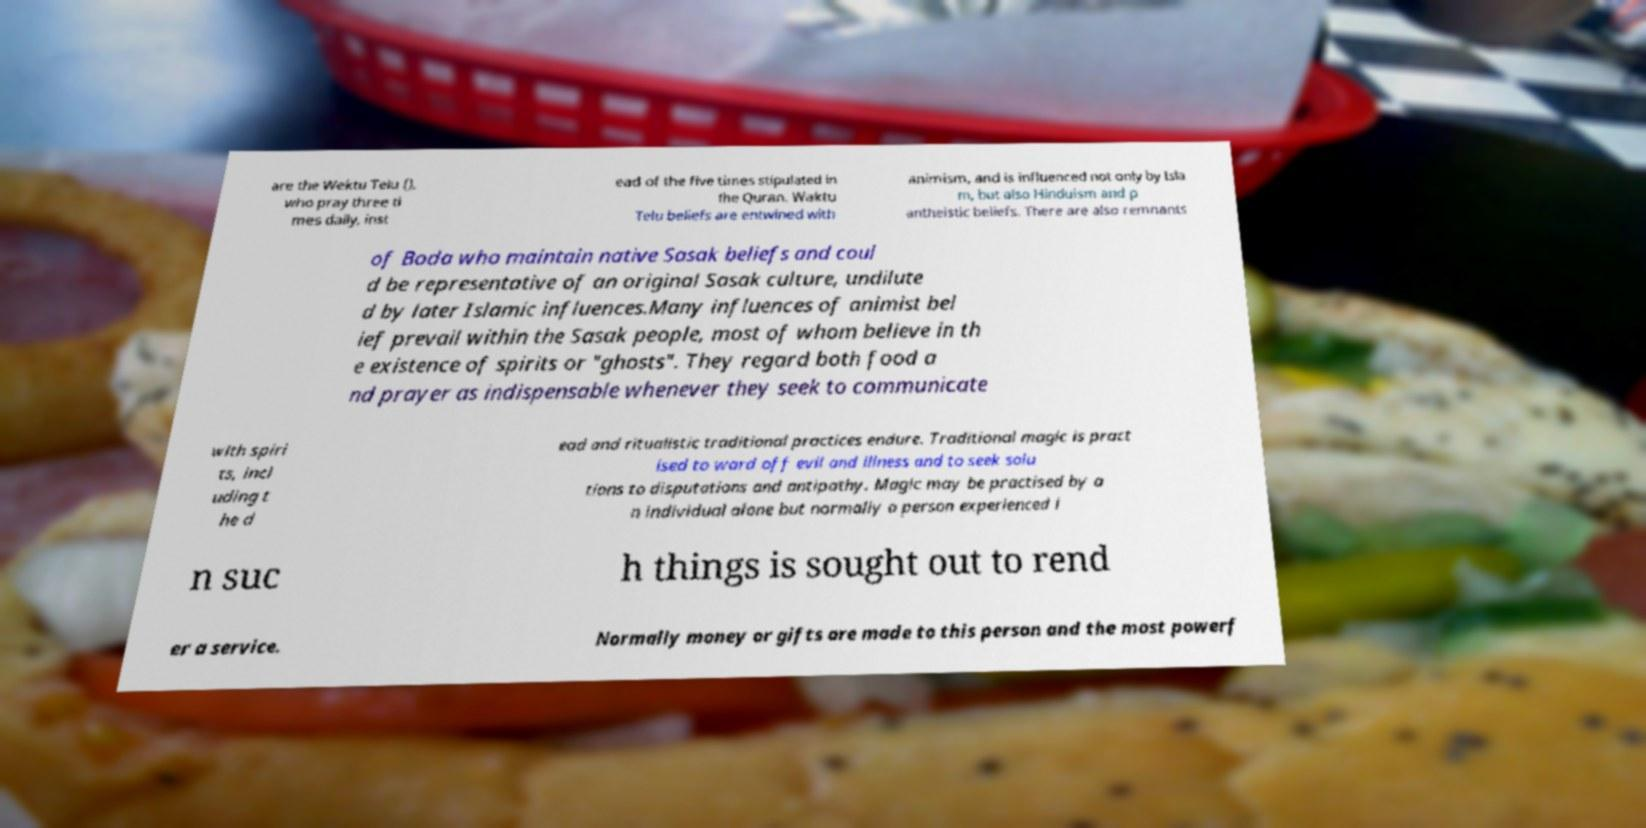Please read and relay the text visible in this image. What does it say? are the Wektu Telu (), who pray three ti mes daily, inst ead of the five times stipulated in the Quran. Waktu Telu beliefs are entwined with animism, and is influenced not only by Isla m, but also Hinduism and p antheistic beliefs. There are also remnants of Boda who maintain native Sasak beliefs and coul d be representative of an original Sasak culture, undilute d by later Islamic influences.Many influences of animist bel ief prevail within the Sasak people, most of whom believe in th e existence of spirits or "ghosts". They regard both food a nd prayer as indispensable whenever they seek to communicate with spiri ts, incl uding t he d ead and ritualistic traditional practices endure. Traditional magic is pract ised to ward off evil and illness and to seek solu tions to disputations and antipathy. Magic may be practised by a n individual alone but normally a person experienced i n suc h things is sought out to rend er a service. Normally money or gifts are made to this person and the most powerf 